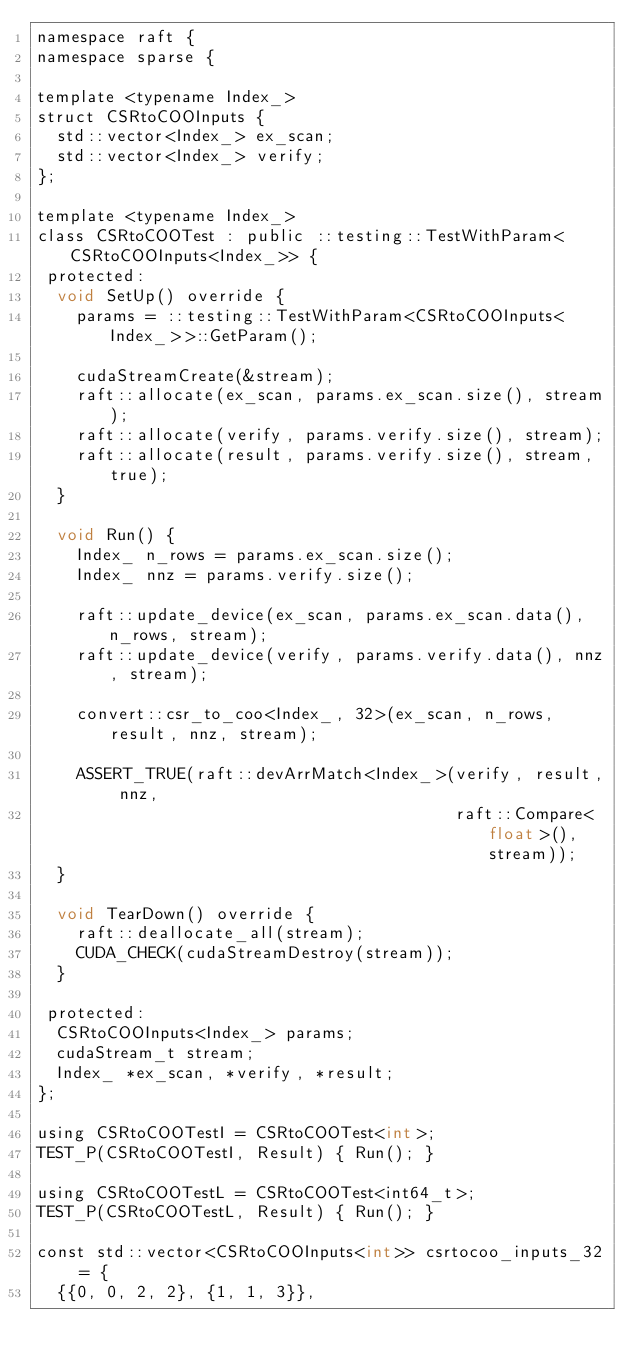Convert code to text. <code><loc_0><loc_0><loc_500><loc_500><_Cuda_>namespace raft {
namespace sparse {

template <typename Index_>
struct CSRtoCOOInputs {
  std::vector<Index_> ex_scan;
  std::vector<Index_> verify;
};

template <typename Index_>
class CSRtoCOOTest : public ::testing::TestWithParam<CSRtoCOOInputs<Index_>> {
 protected:
  void SetUp() override {
    params = ::testing::TestWithParam<CSRtoCOOInputs<Index_>>::GetParam();

    cudaStreamCreate(&stream);
    raft::allocate(ex_scan, params.ex_scan.size(), stream);
    raft::allocate(verify, params.verify.size(), stream);
    raft::allocate(result, params.verify.size(), stream, true);
  }

  void Run() {
    Index_ n_rows = params.ex_scan.size();
    Index_ nnz = params.verify.size();

    raft::update_device(ex_scan, params.ex_scan.data(), n_rows, stream);
    raft::update_device(verify, params.verify.data(), nnz, stream);

    convert::csr_to_coo<Index_, 32>(ex_scan, n_rows, result, nnz, stream);

    ASSERT_TRUE(raft::devArrMatch<Index_>(verify, result, nnz,
                                          raft::Compare<float>(), stream));
  }

  void TearDown() override {
    raft::deallocate_all(stream);
    CUDA_CHECK(cudaStreamDestroy(stream));
  }

 protected:
  CSRtoCOOInputs<Index_> params;
  cudaStream_t stream;
  Index_ *ex_scan, *verify, *result;
};

using CSRtoCOOTestI = CSRtoCOOTest<int>;
TEST_P(CSRtoCOOTestI, Result) { Run(); }

using CSRtoCOOTestL = CSRtoCOOTest<int64_t>;
TEST_P(CSRtoCOOTestL, Result) { Run(); }

const std::vector<CSRtoCOOInputs<int>> csrtocoo_inputs_32 = {
  {{0, 0, 2, 2}, {1, 1, 3}},</code> 